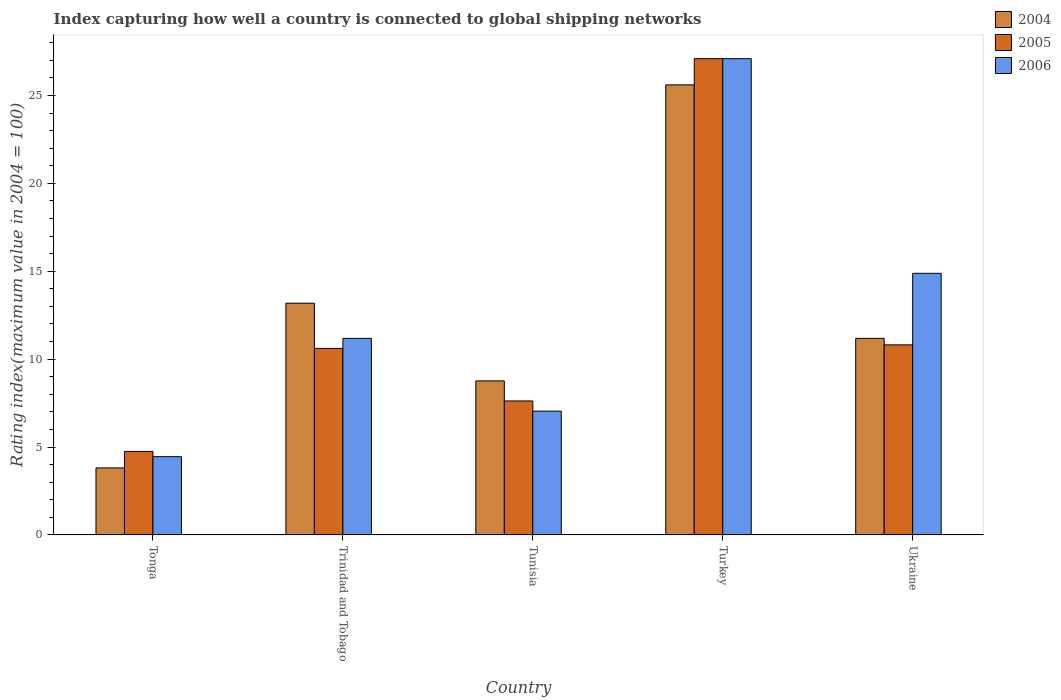How many different coloured bars are there?
Provide a succinct answer. 3. Are the number of bars per tick equal to the number of legend labels?
Provide a succinct answer. Yes. How many bars are there on the 3rd tick from the left?
Provide a succinct answer. 3. How many bars are there on the 1st tick from the right?
Offer a very short reply. 3. What is the label of the 2nd group of bars from the left?
Your answer should be very brief. Trinidad and Tobago. In how many cases, is the number of bars for a given country not equal to the number of legend labels?
Provide a succinct answer. 0. What is the rating index in 2005 in Trinidad and Tobago?
Make the answer very short. 10.61. Across all countries, what is the maximum rating index in 2006?
Keep it short and to the point. 27.09. Across all countries, what is the minimum rating index in 2005?
Provide a succinct answer. 4.75. In which country was the rating index in 2005 minimum?
Offer a terse response. Tonga. What is the total rating index in 2006 in the graph?
Your answer should be compact. 64.64. What is the difference between the rating index in 2006 in Trinidad and Tobago and that in Ukraine?
Your answer should be very brief. -3.7. What is the difference between the rating index in 2006 in Tonga and the rating index in 2004 in Turkey?
Provide a short and direct response. -21.15. What is the average rating index in 2004 per country?
Provide a short and direct response. 12.51. What is the difference between the rating index of/in 2004 and rating index of/in 2006 in Turkey?
Keep it short and to the point. -1.49. In how many countries, is the rating index in 2006 greater than 7?
Ensure brevity in your answer.  4. What is the ratio of the rating index in 2005 in Tonga to that in Turkey?
Your response must be concise. 0.18. Is the rating index in 2005 in Trinidad and Tobago less than that in Tunisia?
Provide a succinct answer. No. Is the difference between the rating index in 2004 in Trinidad and Tobago and Ukraine greater than the difference between the rating index in 2006 in Trinidad and Tobago and Ukraine?
Your response must be concise. Yes. What is the difference between the highest and the second highest rating index in 2004?
Offer a very short reply. 14.42. What is the difference between the highest and the lowest rating index in 2006?
Your response must be concise. 22.64. In how many countries, is the rating index in 2005 greater than the average rating index in 2005 taken over all countries?
Your response must be concise. 1. What does the 2nd bar from the left in Trinidad and Tobago represents?
Your answer should be very brief. 2005. What does the 1st bar from the right in Ukraine represents?
Offer a very short reply. 2006. Are all the bars in the graph horizontal?
Keep it short and to the point. No. What is the difference between two consecutive major ticks on the Y-axis?
Give a very brief answer. 5. Are the values on the major ticks of Y-axis written in scientific E-notation?
Keep it short and to the point. No. Does the graph contain grids?
Your answer should be very brief. No. How many legend labels are there?
Give a very brief answer. 3. What is the title of the graph?
Keep it short and to the point. Index capturing how well a country is connected to global shipping networks. Does "1991" appear as one of the legend labels in the graph?
Keep it short and to the point. No. What is the label or title of the X-axis?
Give a very brief answer. Country. What is the label or title of the Y-axis?
Your answer should be compact. Rating index(maximum value in 2004 = 100). What is the Rating index(maximum value in 2004 = 100) of 2004 in Tonga?
Give a very brief answer. 3.81. What is the Rating index(maximum value in 2004 = 100) in 2005 in Tonga?
Your response must be concise. 4.75. What is the Rating index(maximum value in 2004 = 100) of 2006 in Tonga?
Your answer should be very brief. 4.45. What is the Rating index(maximum value in 2004 = 100) of 2004 in Trinidad and Tobago?
Offer a very short reply. 13.18. What is the Rating index(maximum value in 2004 = 100) of 2005 in Trinidad and Tobago?
Ensure brevity in your answer.  10.61. What is the Rating index(maximum value in 2004 = 100) in 2006 in Trinidad and Tobago?
Keep it short and to the point. 11.18. What is the Rating index(maximum value in 2004 = 100) of 2004 in Tunisia?
Offer a terse response. 8.76. What is the Rating index(maximum value in 2004 = 100) in 2005 in Tunisia?
Make the answer very short. 7.62. What is the Rating index(maximum value in 2004 = 100) of 2006 in Tunisia?
Your response must be concise. 7.04. What is the Rating index(maximum value in 2004 = 100) of 2004 in Turkey?
Provide a short and direct response. 25.6. What is the Rating index(maximum value in 2004 = 100) in 2005 in Turkey?
Offer a very short reply. 27.09. What is the Rating index(maximum value in 2004 = 100) in 2006 in Turkey?
Make the answer very short. 27.09. What is the Rating index(maximum value in 2004 = 100) in 2004 in Ukraine?
Your response must be concise. 11.18. What is the Rating index(maximum value in 2004 = 100) of 2005 in Ukraine?
Your answer should be very brief. 10.81. What is the Rating index(maximum value in 2004 = 100) of 2006 in Ukraine?
Offer a terse response. 14.88. Across all countries, what is the maximum Rating index(maximum value in 2004 = 100) in 2004?
Offer a terse response. 25.6. Across all countries, what is the maximum Rating index(maximum value in 2004 = 100) in 2005?
Your response must be concise. 27.09. Across all countries, what is the maximum Rating index(maximum value in 2004 = 100) of 2006?
Offer a very short reply. 27.09. Across all countries, what is the minimum Rating index(maximum value in 2004 = 100) of 2004?
Ensure brevity in your answer.  3.81. Across all countries, what is the minimum Rating index(maximum value in 2004 = 100) in 2005?
Provide a short and direct response. 4.75. Across all countries, what is the minimum Rating index(maximum value in 2004 = 100) of 2006?
Provide a succinct answer. 4.45. What is the total Rating index(maximum value in 2004 = 100) in 2004 in the graph?
Keep it short and to the point. 62.53. What is the total Rating index(maximum value in 2004 = 100) in 2005 in the graph?
Make the answer very short. 60.88. What is the total Rating index(maximum value in 2004 = 100) in 2006 in the graph?
Your response must be concise. 64.64. What is the difference between the Rating index(maximum value in 2004 = 100) in 2004 in Tonga and that in Trinidad and Tobago?
Your answer should be compact. -9.37. What is the difference between the Rating index(maximum value in 2004 = 100) of 2005 in Tonga and that in Trinidad and Tobago?
Provide a short and direct response. -5.86. What is the difference between the Rating index(maximum value in 2004 = 100) of 2006 in Tonga and that in Trinidad and Tobago?
Ensure brevity in your answer.  -6.73. What is the difference between the Rating index(maximum value in 2004 = 100) of 2004 in Tonga and that in Tunisia?
Keep it short and to the point. -4.95. What is the difference between the Rating index(maximum value in 2004 = 100) of 2005 in Tonga and that in Tunisia?
Your answer should be compact. -2.87. What is the difference between the Rating index(maximum value in 2004 = 100) in 2006 in Tonga and that in Tunisia?
Your answer should be very brief. -2.59. What is the difference between the Rating index(maximum value in 2004 = 100) of 2004 in Tonga and that in Turkey?
Give a very brief answer. -21.79. What is the difference between the Rating index(maximum value in 2004 = 100) in 2005 in Tonga and that in Turkey?
Give a very brief answer. -22.34. What is the difference between the Rating index(maximum value in 2004 = 100) of 2006 in Tonga and that in Turkey?
Give a very brief answer. -22.64. What is the difference between the Rating index(maximum value in 2004 = 100) of 2004 in Tonga and that in Ukraine?
Offer a terse response. -7.37. What is the difference between the Rating index(maximum value in 2004 = 100) of 2005 in Tonga and that in Ukraine?
Give a very brief answer. -6.06. What is the difference between the Rating index(maximum value in 2004 = 100) in 2006 in Tonga and that in Ukraine?
Your answer should be very brief. -10.43. What is the difference between the Rating index(maximum value in 2004 = 100) of 2004 in Trinidad and Tobago and that in Tunisia?
Offer a terse response. 4.42. What is the difference between the Rating index(maximum value in 2004 = 100) in 2005 in Trinidad and Tobago and that in Tunisia?
Ensure brevity in your answer.  2.99. What is the difference between the Rating index(maximum value in 2004 = 100) of 2006 in Trinidad and Tobago and that in Tunisia?
Offer a terse response. 4.14. What is the difference between the Rating index(maximum value in 2004 = 100) in 2004 in Trinidad and Tobago and that in Turkey?
Provide a succinct answer. -12.42. What is the difference between the Rating index(maximum value in 2004 = 100) of 2005 in Trinidad and Tobago and that in Turkey?
Make the answer very short. -16.48. What is the difference between the Rating index(maximum value in 2004 = 100) of 2006 in Trinidad and Tobago and that in Turkey?
Provide a succinct answer. -15.91. What is the difference between the Rating index(maximum value in 2004 = 100) of 2004 in Trinidad and Tobago and that in Ukraine?
Make the answer very short. 2. What is the difference between the Rating index(maximum value in 2004 = 100) of 2004 in Tunisia and that in Turkey?
Make the answer very short. -16.84. What is the difference between the Rating index(maximum value in 2004 = 100) in 2005 in Tunisia and that in Turkey?
Keep it short and to the point. -19.47. What is the difference between the Rating index(maximum value in 2004 = 100) of 2006 in Tunisia and that in Turkey?
Make the answer very short. -20.05. What is the difference between the Rating index(maximum value in 2004 = 100) of 2004 in Tunisia and that in Ukraine?
Keep it short and to the point. -2.42. What is the difference between the Rating index(maximum value in 2004 = 100) in 2005 in Tunisia and that in Ukraine?
Give a very brief answer. -3.19. What is the difference between the Rating index(maximum value in 2004 = 100) in 2006 in Tunisia and that in Ukraine?
Give a very brief answer. -7.84. What is the difference between the Rating index(maximum value in 2004 = 100) in 2004 in Turkey and that in Ukraine?
Offer a terse response. 14.42. What is the difference between the Rating index(maximum value in 2004 = 100) of 2005 in Turkey and that in Ukraine?
Make the answer very short. 16.28. What is the difference between the Rating index(maximum value in 2004 = 100) in 2006 in Turkey and that in Ukraine?
Keep it short and to the point. 12.21. What is the difference between the Rating index(maximum value in 2004 = 100) in 2004 in Tonga and the Rating index(maximum value in 2004 = 100) in 2005 in Trinidad and Tobago?
Your response must be concise. -6.8. What is the difference between the Rating index(maximum value in 2004 = 100) of 2004 in Tonga and the Rating index(maximum value in 2004 = 100) of 2006 in Trinidad and Tobago?
Give a very brief answer. -7.37. What is the difference between the Rating index(maximum value in 2004 = 100) of 2005 in Tonga and the Rating index(maximum value in 2004 = 100) of 2006 in Trinidad and Tobago?
Keep it short and to the point. -6.43. What is the difference between the Rating index(maximum value in 2004 = 100) in 2004 in Tonga and the Rating index(maximum value in 2004 = 100) in 2005 in Tunisia?
Provide a short and direct response. -3.81. What is the difference between the Rating index(maximum value in 2004 = 100) of 2004 in Tonga and the Rating index(maximum value in 2004 = 100) of 2006 in Tunisia?
Offer a terse response. -3.23. What is the difference between the Rating index(maximum value in 2004 = 100) in 2005 in Tonga and the Rating index(maximum value in 2004 = 100) in 2006 in Tunisia?
Offer a very short reply. -2.29. What is the difference between the Rating index(maximum value in 2004 = 100) of 2004 in Tonga and the Rating index(maximum value in 2004 = 100) of 2005 in Turkey?
Offer a terse response. -23.28. What is the difference between the Rating index(maximum value in 2004 = 100) in 2004 in Tonga and the Rating index(maximum value in 2004 = 100) in 2006 in Turkey?
Your answer should be very brief. -23.28. What is the difference between the Rating index(maximum value in 2004 = 100) of 2005 in Tonga and the Rating index(maximum value in 2004 = 100) of 2006 in Turkey?
Keep it short and to the point. -22.34. What is the difference between the Rating index(maximum value in 2004 = 100) in 2004 in Tonga and the Rating index(maximum value in 2004 = 100) in 2006 in Ukraine?
Offer a terse response. -11.07. What is the difference between the Rating index(maximum value in 2004 = 100) in 2005 in Tonga and the Rating index(maximum value in 2004 = 100) in 2006 in Ukraine?
Provide a short and direct response. -10.13. What is the difference between the Rating index(maximum value in 2004 = 100) in 2004 in Trinidad and Tobago and the Rating index(maximum value in 2004 = 100) in 2005 in Tunisia?
Give a very brief answer. 5.56. What is the difference between the Rating index(maximum value in 2004 = 100) of 2004 in Trinidad and Tobago and the Rating index(maximum value in 2004 = 100) of 2006 in Tunisia?
Offer a very short reply. 6.14. What is the difference between the Rating index(maximum value in 2004 = 100) in 2005 in Trinidad and Tobago and the Rating index(maximum value in 2004 = 100) in 2006 in Tunisia?
Offer a very short reply. 3.57. What is the difference between the Rating index(maximum value in 2004 = 100) of 2004 in Trinidad and Tobago and the Rating index(maximum value in 2004 = 100) of 2005 in Turkey?
Provide a succinct answer. -13.91. What is the difference between the Rating index(maximum value in 2004 = 100) in 2004 in Trinidad and Tobago and the Rating index(maximum value in 2004 = 100) in 2006 in Turkey?
Offer a terse response. -13.91. What is the difference between the Rating index(maximum value in 2004 = 100) of 2005 in Trinidad and Tobago and the Rating index(maximum value in 2004 = 100) of 2006 in Turkey?
Offer a very short reply. -16.48. What is the difference between the Rating index(maximum value in 2004 = 100) of 2004 in Trinidad and Tobago and the Rating index(maximum value in 2004 = 100) of 2005 in Ukraine?
Your response must be concise. 2.37. What is the difference between the Rating index(maximum value in 2004 = 100) of 2004 in Trinidad and Tobago and the Rating index(maximum value in 2004 = 100) of 2006 in Ukraine?
Keep it short and to the point. -1.7. What is the difference between the Rating index(maximum value in 2004 = 100) in 2005 in Trinidad and Tobago and the Rating index(maximum value in 2004 = 100) in 2006 in Ukraine?
Your response must be concise. -4.27. What is the difference between the Rating index(maximum value in 2004 = 100) of 2004 in Tunisia and the Rating index(maximum value in 2004 = 100) of 2005 in Turkey?
Make the answer very short. -18.33. What is the difference between the Rating index(maximum value in 2004 = 100) of 2004 in Tunisia and the Rating index(maximum value in 2004 = 100) of 2006 in Turkey?
Your response must be concise. -18.33. What is the difference between the Rating index(maximum value in 2004 = 100) of 2005 in Tunisia and the Rating index(maximum value in 2004 = 100) of 2006 in Turkey?
Your answer should be very brief. -19.47. What is the difference between the Rating index(maximum value in 2004 = 100) of 2004 in Tunisia and the Rating index(maximum value in 2004 = 100) of 2005 in Ukraine?
Your answer should be compact. -2.05. What is the difference between the Rating index(maximum value in 2004 = 100) of 2004 in Tunisia and the Rating index(maximum value in 2004 = 100) of 2006 in Ukraine?
Provide a short and direct response. -6.12. What is the difference between the Rating index(maximum value in 2004 = 100) in 2005 in Tunisia and the Rating index(maximum value in 2004 = 100) in 2006 in Ukraine?
Your response must be concise. -7.26. What is the difference between the Rating index(maximum value in 2004 = 100) in 2004 in Turkey and the Rating index(maximum value in 2004 = 100) in 2005 in Ukraine?
Keep it short and to the point. 14.79. What is the difference between the Rating index(maximum value in 2004 = 100) in 2004 in Turkey and the Rating index(maximum value in 2004 = 100) in 2006 in Ukraine?
Offer a very short reply. 10.72. What is the difference between the Rating index(maximum value in 2004 = 100) in 2005 in Turkey and the Rating index(maximum value in 2004 = 100) in 2006 in Ukraine?
Offer a very short reply. 12.21. What is the average Rating index(maximum value in 2004 = 100) in 2004 per country?
Give a very brief answer. 12.51. What is the average Rating index(maximum value in 2004 = 100) of 2005 per country?
Make the answer very short. 12.18. What is the average Rating index(maximum value in 2004 = 100) in 2006 per country?
Your response must be concise. 12.93. What is the difference between the Rating index(maximum value in 2004 = 100) of 2004 and Rating index(maximum value in 2004 = 100) of 2005 in Tonga?
Make the answer very short. -0.94. What is the difference between the Rating index(maximum value in 2004 = 100) in 2004 and Rating index(maximum value in 2004 = 100) in 2006 in Tonga?
Give a very brief answer. -0.64. What is the difference between the Rating index(maximum value in 2004 = 100) of 2004 and Rating index(maximum value in 2004 = 100) of 2005 in Trinidad and Tobago?
Your answer should be very brief. 2.57. What is the difference between the Rating index(maximum value in 2004 = 100) of 2005 and Rating index(maximum value in 2004 = 100) of 2006 in Trinidad and Tobago?
Provide a short and direct response. -0.57. What is the difference between the Rating index(maximum value in 2004 = 100) in 2004 and Rating index(maximum value in 2004 = 100) in 2005 in Tunisia?
Your answer should be compact. 1.14. What is the difference between the Rating index(maximum value in 2004 = 100) in 2004 and Rating index(maximum value in 2004 = 100) in 2006 in Tunisia?
Provide a short and direct response. 1.72. What is the difference between the Rating index(maximum value in 2004 = 100) of 2005 and Rating index(maximum value in 2004 = 100) of 2006 in Tunisia?
Provide a succinct answer. 0.58. What is the difference between the Rating index(maximum value in 2004 = 100) in 2004 and Rating index(maximum value in 2004 = 100) in 2005 in Turkey?
Your response must be concise. -1.49. What is the difference between the Rating index(maximum value in 2004 = 100) in 2004 and Rating index(maximum value in 2004 = 100) in 2006 in Turkey?
Provide a succinct answer. -1.49. What is the difference between the Rating index(maximum value in 2004 = 100) of 2004 and Rating index(maximum value in 2004 = 100) of 2005 in Ukraine?
Keep it short and to the point. 0.37. What is the difference between the Rating index(maximum value in 2004 = 100) in 2004 and Rating index(maximum value in 2004 = 100) in 2006 in Ukraine?
Provide a succinct answer. -3.7. What is the difference between the Rating index(maximum value in 2004 = 100) in 2005 and Rating index(maximum value in 2004 = 100) in 2006 in Ukraine?
Give a very brief answer. -4.07. What is the ratio of the Rating index(maximum value in 2004 = 100) of 2004 in Tonga to that in Trinidad and Tobago?
Make the answer very short. 0.29. What is the ratio of the Rating index(maximum value in 2004 = 100) in 2005 in Tonga to that in Trinidad and Tobago?
Your answer should be very brief. 0.45. What is the ratio of the Rating index(maximum value in 2004 = 100) of 2006 in Tonga to that in Trinidad and Tobago?
Give a very brief answer. 0.4. What is the ratio of the Rating index(maximum value in 2004 = 100) of 2004 in Tonga to that in Tunisia?
Offer a terse response. 0.43. What is the ratio of the Rating index(maximum value in 2004 = 100) in 2005 in Tonga to that in Tunisia?
Your answer should be very brief. 0.62. What is the ratio of the Rating index(maximum value in 2004 = 100) of 2006 in Tonga to that in Tunisia?
Offer a very short reply. 0.63. What is the ratio of the Rating index(maximum value in 2004 = 100) of 2004 in Tonga to that in Turkey?
Your answer should be compact. 0.15. What is the ratio of the Rating index(maximum value in 2004 = 100) in 2005 in Tonga to that in Turkey?
Your answer should be very brief. 0.18. What is the ratio of the Rating index(maximum value in 2004 = 100) of 2006 in Tonga to that in Turkey?
Provide a succinct answer. 0.16. What is the ratio of the Rating index(maximum value in 2004 = 100) of 2004 in Tonga to that in Ukraine?
Ensure brevity in your answer.  0.34. What is the ratio of the Rating index(maximum value in 2004 = 100) of 2005 in Tonga to that in Ukraine?
Ensure brevity in your answer.  0.44. What is the ratio of the Rating index(maximum value in 2004 = 100) of 2006 in Tonga to that in Ukraine?
Keep it short and to the point. 0.3. What is the ratio of the Rating index(maximum value in 2004 = 100) of 2004 in Trinidad and Tobago to that in Tunisia?
Give a very brief answer. 1.5. What is the ratio of the Rating index(maximum value in 2004 = 100) of 2005 in Trinidad and Tobago to that in Tunisia?
Provide a short and direct response. 1.39. What is the ratio of the Rating index(maximum value in 2004 = 100) of 2006 in Trinidad and Tobago to that in Tunisia?
Ensure brevity in your answer.  1.59. What is the ratio of the Rating index(maximum value in 2004 = 100) in 2004 in Trinidad and Tobago to that in Turkey?
Your answer should be very brief. 0.51. What is the ratio of the Rating index(maximum value in 2004 = 100) of 2005 in Trinidad and Tobago to that in Turkey?
Give a very brief answer. 0.39. What is the ratio of the Rating index(maximum value in 2004 = 100) in 2006 in Trinidad and Tobago to that in Turkey?
Offer a terse response. 0.41. What is the ratio of the Rating index(maximum value in 2004 = 100) in 2004 in Trinidad and Tobago to that in Ukraine?
Keep it short and to the point. 1.18. What is the ratio of the Rating index(maximum value in 2004 = 100) in 2005 in Trinidad and Tobago to that in Ukraine?
Provide a succinct answer. 0.98. What is the ratio of the Rating index(maximum value in 2004 = 100) in 2006 in Trinidad and Tobago to that in Ukraine?
Offer a terse response. 0.75. What is the ratio of the Rating index(maximum value in 2004 = 100) of 2004 in Tunisia to that in Turkey?
Make the answer very short. 0.34. What is the ratio of the Rating index(maximum value in 2004 = 100) in 2005 in Tunisia to that in Turkey?
Your answer should be very brief. 0.28. What is the ratio of the Rating index(maximum value in 2004 = 100) of 2006 in Tunisia to that in Turkey?
Your answer should be very brief. 0.26. What is the ratio of the Rating index(maximum value in 2004 = 100) of 2004 in Tunisia to that in Ukraine?
Offer a very short reply. 0.78. What is the ratio of the Rating index(maximum value in 2004 = 100) of 2005 in Tunisia to that in Ukraine?
Offer a very short reply. 0.7. What is the ratio of the Rating index(maximum value in 2004 = 100) in 2006 in Tunisia to that in Ukraine?
Your answer should be very brief. 0.47. What is the ratio of the Rating index(maximum value in 2004 = 100) in 2004 in Turkey to that in Ukraine?
Your answer should be very brief. 2.29. What is the ratio of the Rating index(maximum value in 2004 = 100) in 2005 in Turkey to that in Ukraine?
Provide a succinct answer. 2.51. What is the ratio of the Rating index(maximum value in 2004 = 100) in 2006 in Turkey to that in Ukraine?
Keep it short and to the point. 1.82. What is the difference between the highest and the second highest Rating index(maximum value in 2004 = 100) in 2004?
Provide a short and direct response. 12.42. What is the difference between the highest and the second highest Rating index(maximum value in 2004 = 100) of 2005?
Provide a succinct answer. 16.28. What is the difference between the highest and the second highest Rating index(maximum value in 2004 = 100) in 2006?
Make the answer very short. 12.21. What is the difference between the highest and the lowest Rating index(maximum value in 2004 = 100) of 2004?
Provide a short and direct response. 21.79. What is the difference between the highest and the lowest Rating index(maximum value in 2004 = 100) in 2005?
Ensure brevity in your answer.  22.34. What is the difference between the highest and the lowest Rating index(maximum value in 2004 = 100) of 2006?
Provide a short and direct response. 22.64. 